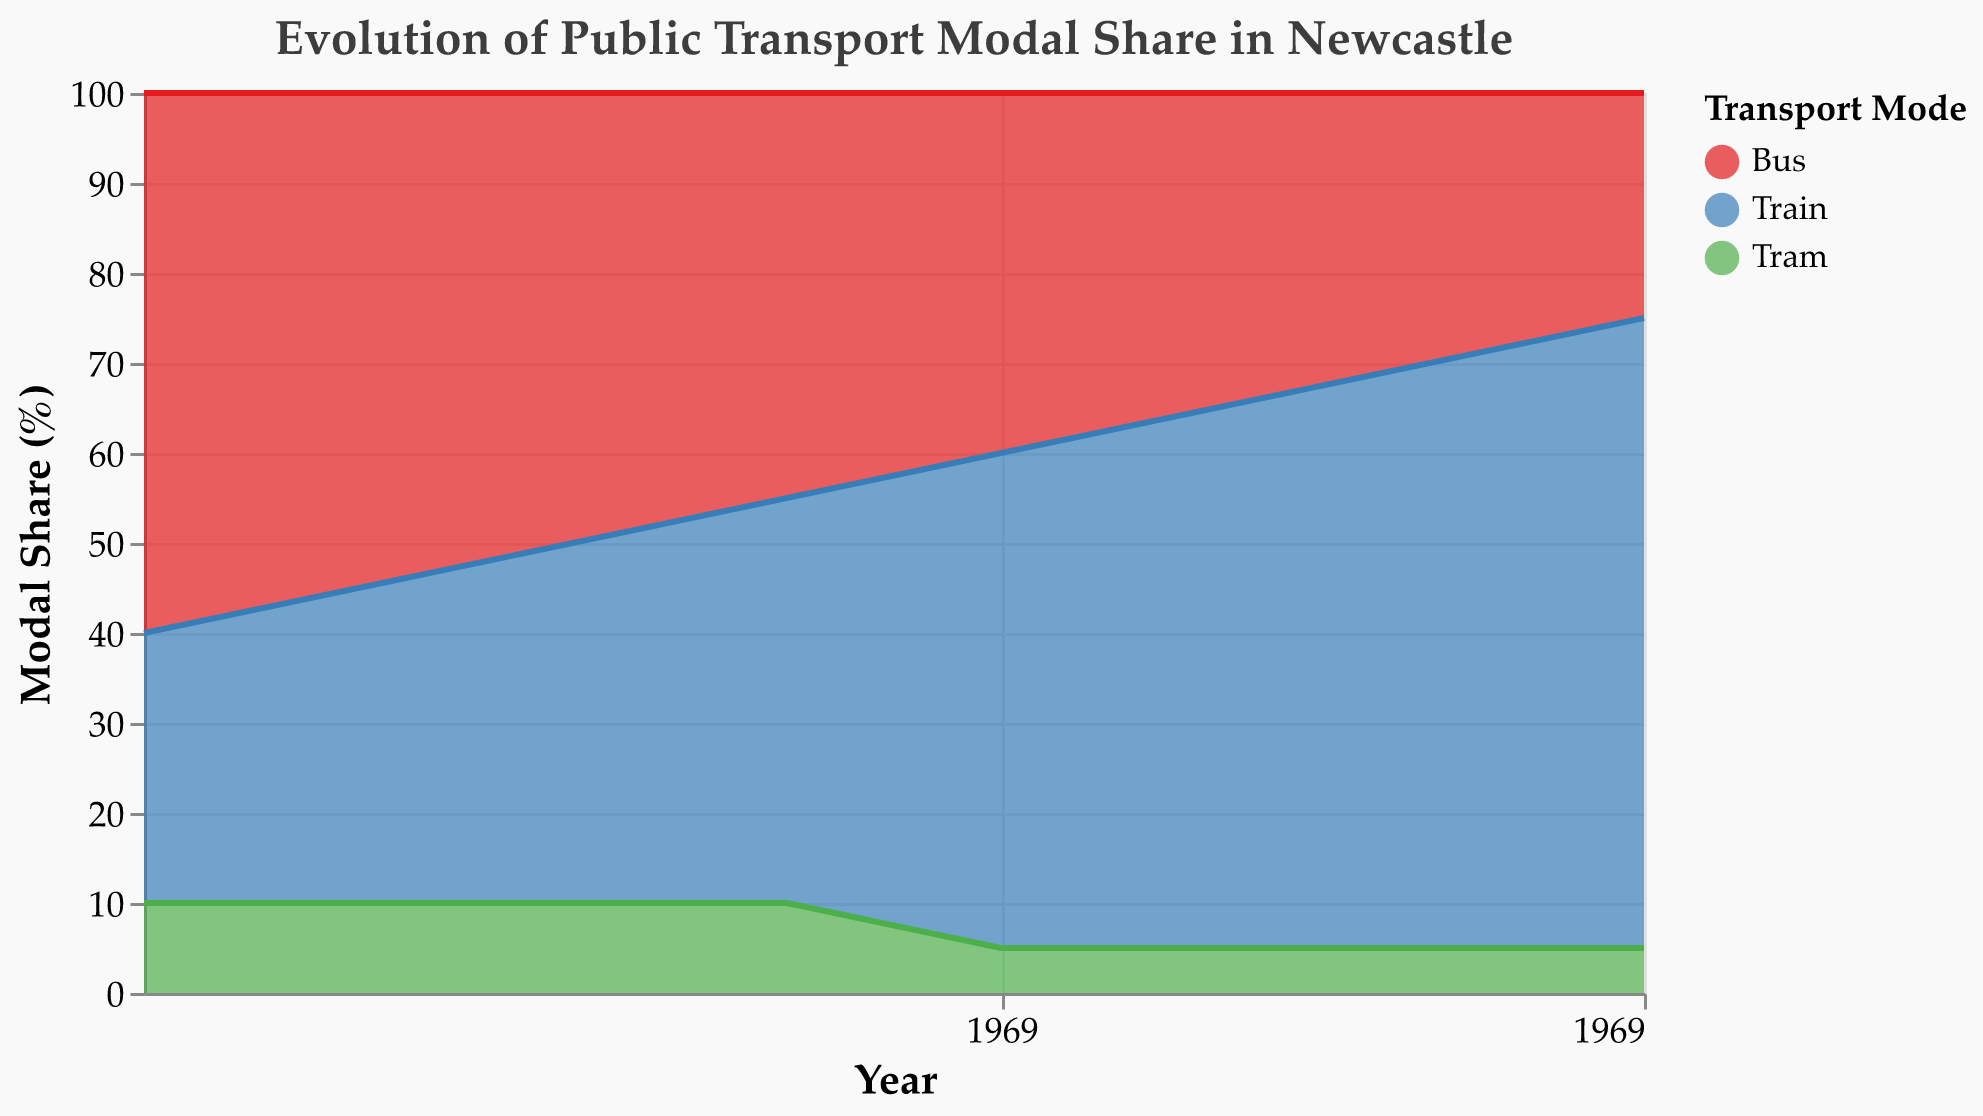When did the tram's modal share decrease from 10% to 5%? The tram's modal share was 10% from the years 1950 to 1980. It decreased to 5% in 1990 and stayed constant onwards. Therefore, the decrease happened between 1980 and 1990.
Answer: Between 1980 and 1990 What is the range of the train's modal share throughout the years? Train's modal share starts at 30% in 1950 and increases progressively to 70% in 2020. Thus, the range is from 30% to 70%.
Answer: 30% to 70% How did the bus's modal share change between 1950 and 2020? The bus's modal share started at 60% in 1950 and decreased steadily over the decades to 25% in 2020.
Answer: Decreased from 60% to 25% Which year marked the highest total share for public transport, including buses, trains, and trams? In an area chart representing modal shares, the total always sums to 100% as it depicts parts of a whole. Hence, every year has a total share of 100% for public transport.
Answer: Every year has 100% Which transport mode had the highest share in 2010? Looking at the data for 2010, the train modal share is 65%, which is higher than both bus (30%) and tram (5%).
Answer: Train Between which years did the train's modal share see the largest increase? Comparing the train's modal shares visually from year to year, the largest increase happens between 1980 (45%) and 1990 (55%), an increase of 10%.
Answer: Between 1980 and 1990 How much did the bus's modal share decrease between 1970 and 2000? The bus's modal share was 50% in 1970 and decreased to 35% in 2000. The difference is 50% - 35% = 15%.
Answer: 15% When did the tram's modal share first drop below 10%? The tram's modal share was 10% from 1950 to 1980. It dropped to 5% in 1990 for the first time.
Answer: 1990 Which two transport modes had equal shares in 1980? In 1980, both buses and trains had an equal modal share of 45%.
Answer: Bus and Train What is the trend in the bus's modal share from 1950 to 2020? Observing the area representing the bus's modal share: it shows a decreasing trend from 1950 at 60% to 25% in 2020.
Answer: Decreasing trend 